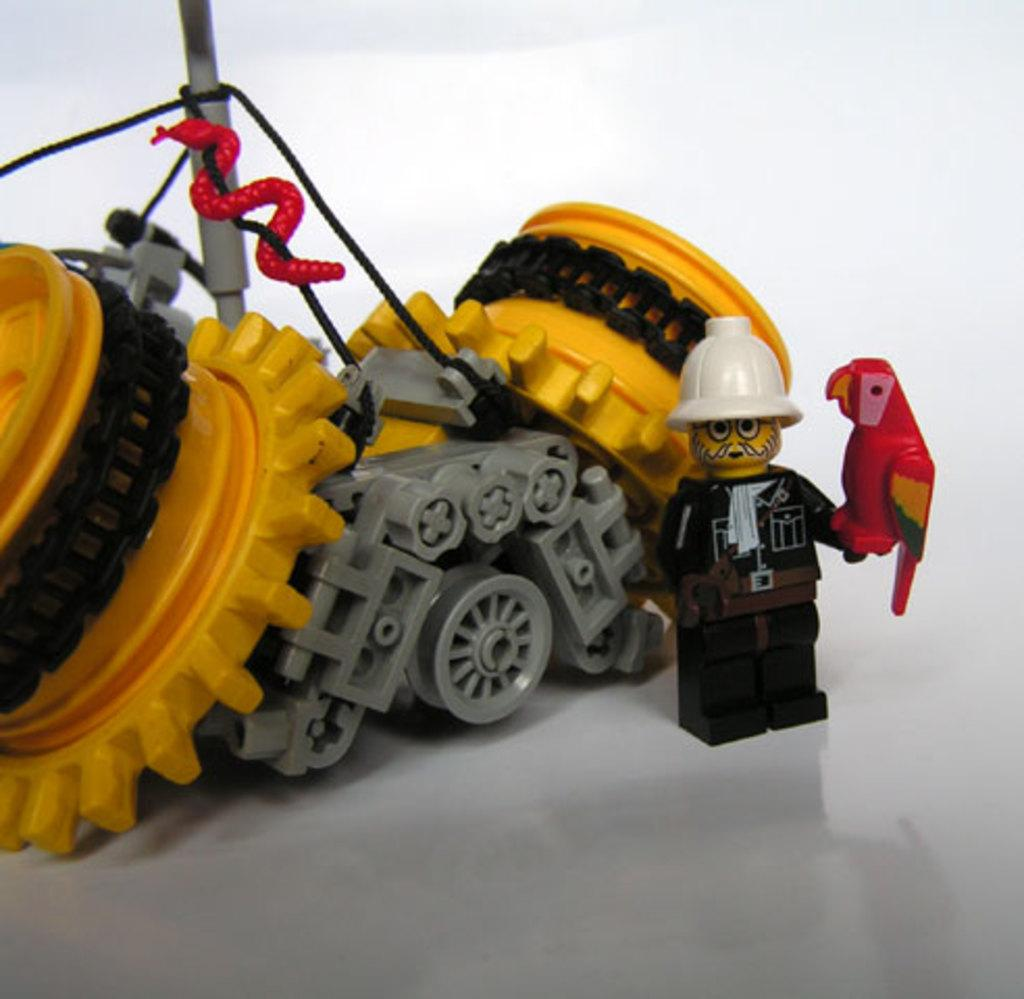What objects are present on the white surface in the image? There are toys on a white surface in the image. What color is the background of the image? The background of the image is white. What type of apparatus is being used by the person in the image? There is no person present in the image, and therefore no apparatus can be observed. Can you describe the condition of the person's knee in the image? There is no person present in the image, and therefore no knee can be observed. 